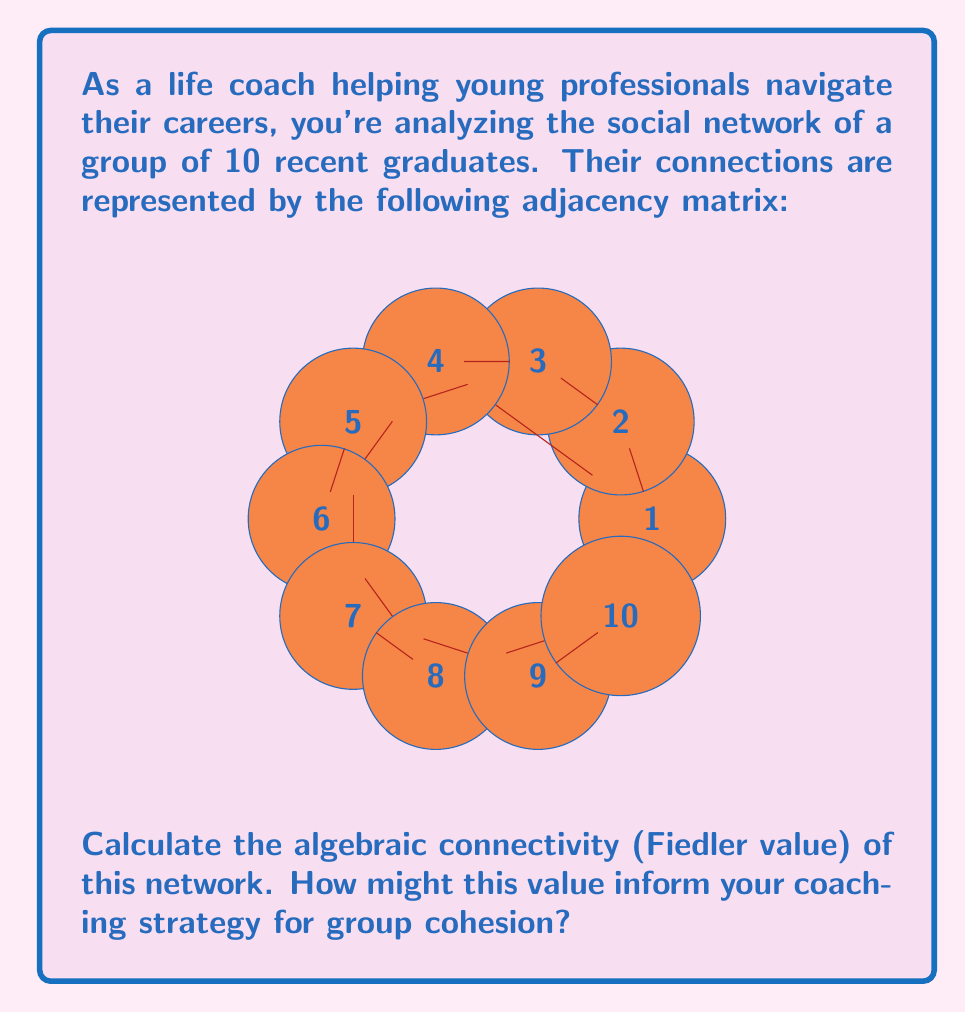Provide a solution to this math problem. To find the algebraic connectivity (Fiedler value) of the network, we need to follow these steps:

1) First, we need to compute the Laplacian matrix $L$ of the graph. The Laplacian matrix is defined as $L = D - A$, where $D$ is the degree matrix and $A$ is the adjacency matrix.

2) The degree matrix $D$ is a diagonal matrix where $D_{ii}$ is the degree of vertex $i$. From the adjacency matrix, we can see:
   $D = diag(2, 2, 3, 3, 3, 3, 3, 3, 2, 2)$

3) Now we can compute $L = D - A$:

   $$L = \begin{bmatrix}
   2 & -1 & 0 & -1 & 0 & 0 & 0 & 0 & 0 & 0 \\
   -1 & 2 & -1 & 0 & 0 & 0 & 0 & 0 & 0 & 0 \\
   0 & -1 & 3 & -1 & -1 & 0 & 0 & 0 & 0 & 0 \\
   -1 & 0 & -1 & 3 & 0 & -1 & 0 & 0 & 0 & 0 \\
   0 & 0 & -1 & 0 & 3 & -1 & -1 & 0 & 0 & 0 \\
   0 & 0 & 0 & -1 & -1 & 3 & 0 & -1 & 0 & 0 \\
   0 & 0 & 0 & 0 & -1 & 0 & 3 & -1 & -1 & 0 \\
   0 & 0 & 0 & 0 & 0 & -1 & -1 & 3 & 0 & -1 \\
   0 & 0 & 0 & 0 & 0 & 0 & -1 & 0 & 2 & -1 \\
   0 & 0 & 0 & 0 & 0 & 0 & 0 & -1 & -1 & 2
   \end{bmatrix}$$

4) The Fiedler value is the second smallest eigenvalue of $L$. We can compute the eigenvalues using a computer algebra system or numerical methods. The eigenvalues of $L$ are approximately:

   $0, 0.3249, 0.8038, 1.1712, 2.0000, 3.0000, 3.4195, 4.0000, 4.6180, 5.6626$

5) The second smallest eigenvalue (Fiedler value) is approximately 0.3249.

This value provides insight into the network's connectivity:

- A higher Fiedler value (closer to 1) indicates better connectivity and more difficulty in partitioning the network.
- A lower value (closer to 0) suggests the network is more easily separated into disconnected components.

In this case, the relatively low Fiedler value (0.3249) suggests that the network has some vulnerability to disconnection and may benefit from strategies to increase cohesion.

As a life coach, this information could inform your strategy by:
1) Identifying potential subgroups within the network.
2) Focusing on strengthening connections between these subgroups.
3) Encouraging activities that promote overall network cohesion.
4) Helping individuals who might be at risk of becoming isolated.
Answer: 0.3249 